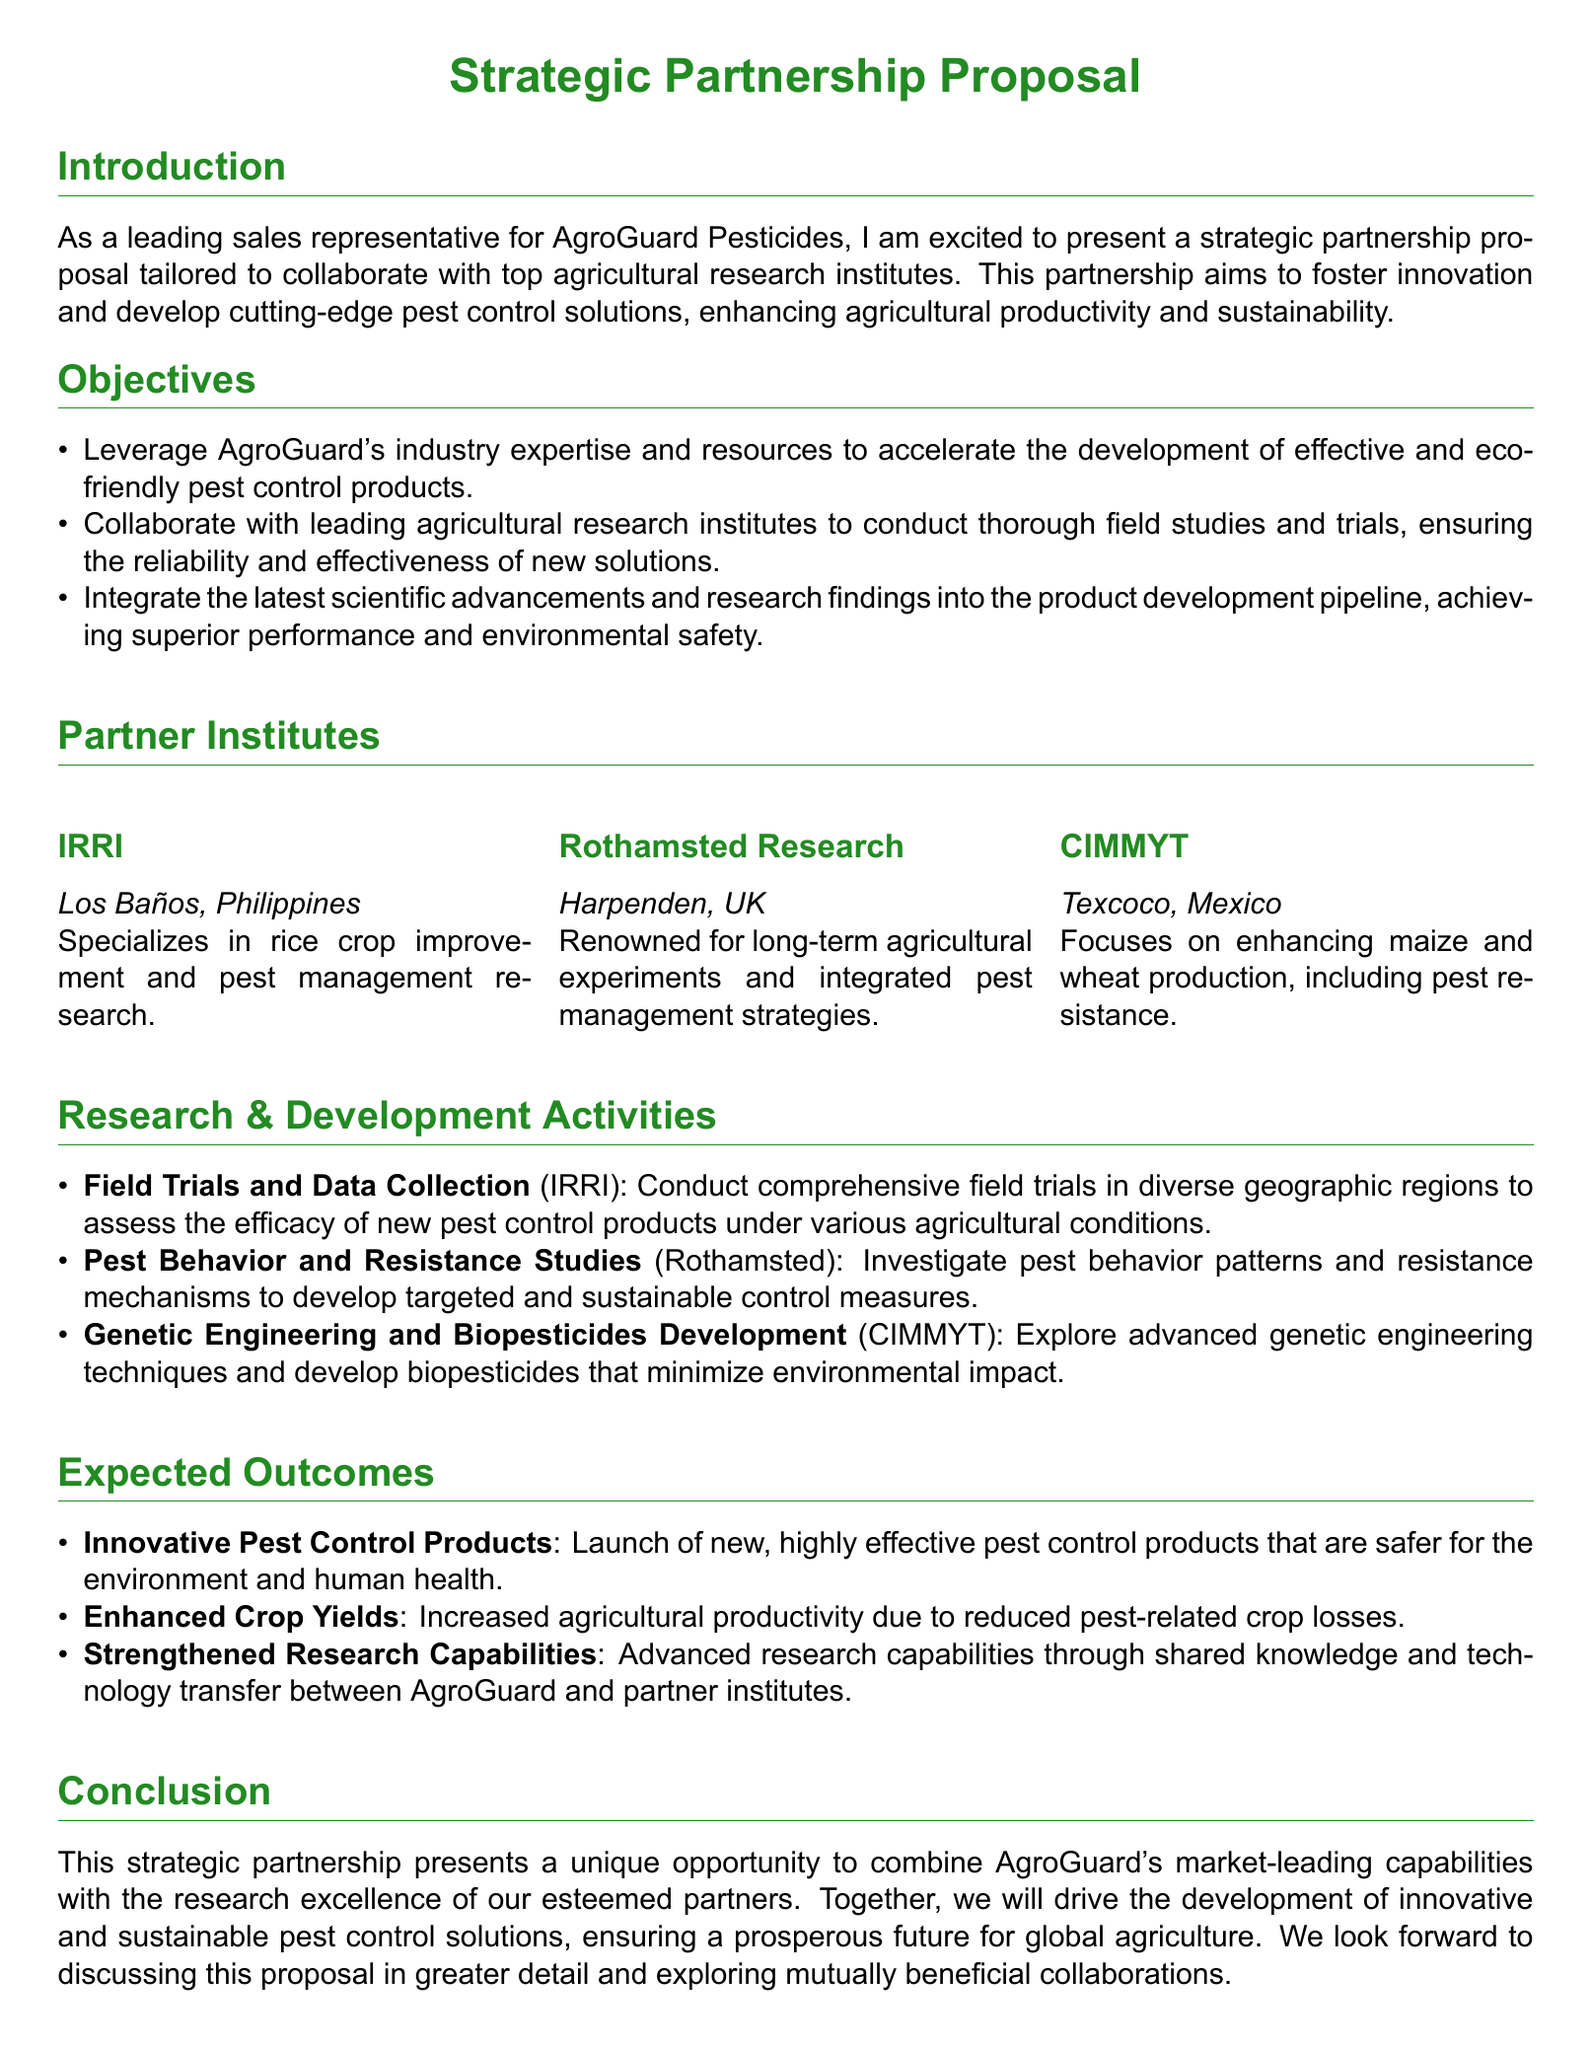What is the name of the company proposing the partnership? The company proposing the partnership is identified as AgroGuard Pesticides.
Answer: AgroGuard Pesticides What are the three partner institutes mentioned? The partner institutes mentioned include IRRI, Rothamsted Research, and CIMMYT.
Answer: IRRI, Rothamsted Research, CIMMYT What is the main objective of the partnership? The primary aim stated for the partnership is to develop effective and eco-friendly pest control products.
Answer: Develop effective and eco-friendly pest control products Where is Rothamsted Research located? The document specifies that Rothamsted Research is located in Harpenden, UK.
Answer: Harpenden, UK What type of trials will be conducted at IRRI? At IRRI, comprehensive field trials will be conducted to assess the efficacy of new pest control products.
Answer: Comprehensive field trials What is expected to increase due to the partnership? The partnership is expected to lead to increased agricultural productivity by reducing pest-related crop losses.
Answer: Increased agricultural productivity Which research activity involves studying pest behavior? The research activity involving studying pest behavior is conducted at Rothamsted, focusing on pest behavior patterns and resistance mechanisms.
Answer: Pest Behavior and Resistance Studies What environmental benefit is associated with new products? The proposed new products are highlighted as being safer for the environment and human health.
Answer: Safer for the environment and human health What type of genetic research will CIMMYT focus on? CIMMYT will focus on advanced genetic engineering techniques and developing biopesticides.
Answer: Genetic engineering techniques and biopesticides 